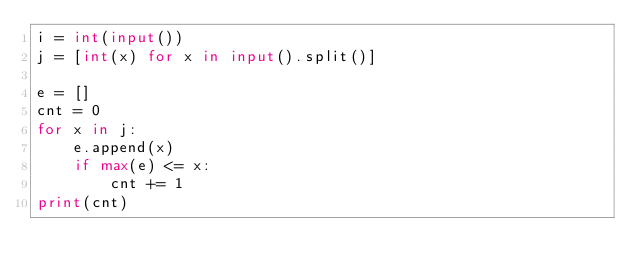<code> <loc_0><loc_0><loc_500><loc_500><_Python_>i = int(input())
j = [int(x) for x in input().split()]

e = []
cnt = 0
for x in j:
    e.append(x)
    if max(e) <= x:
        cnt += 1
print(cnt)</code> 